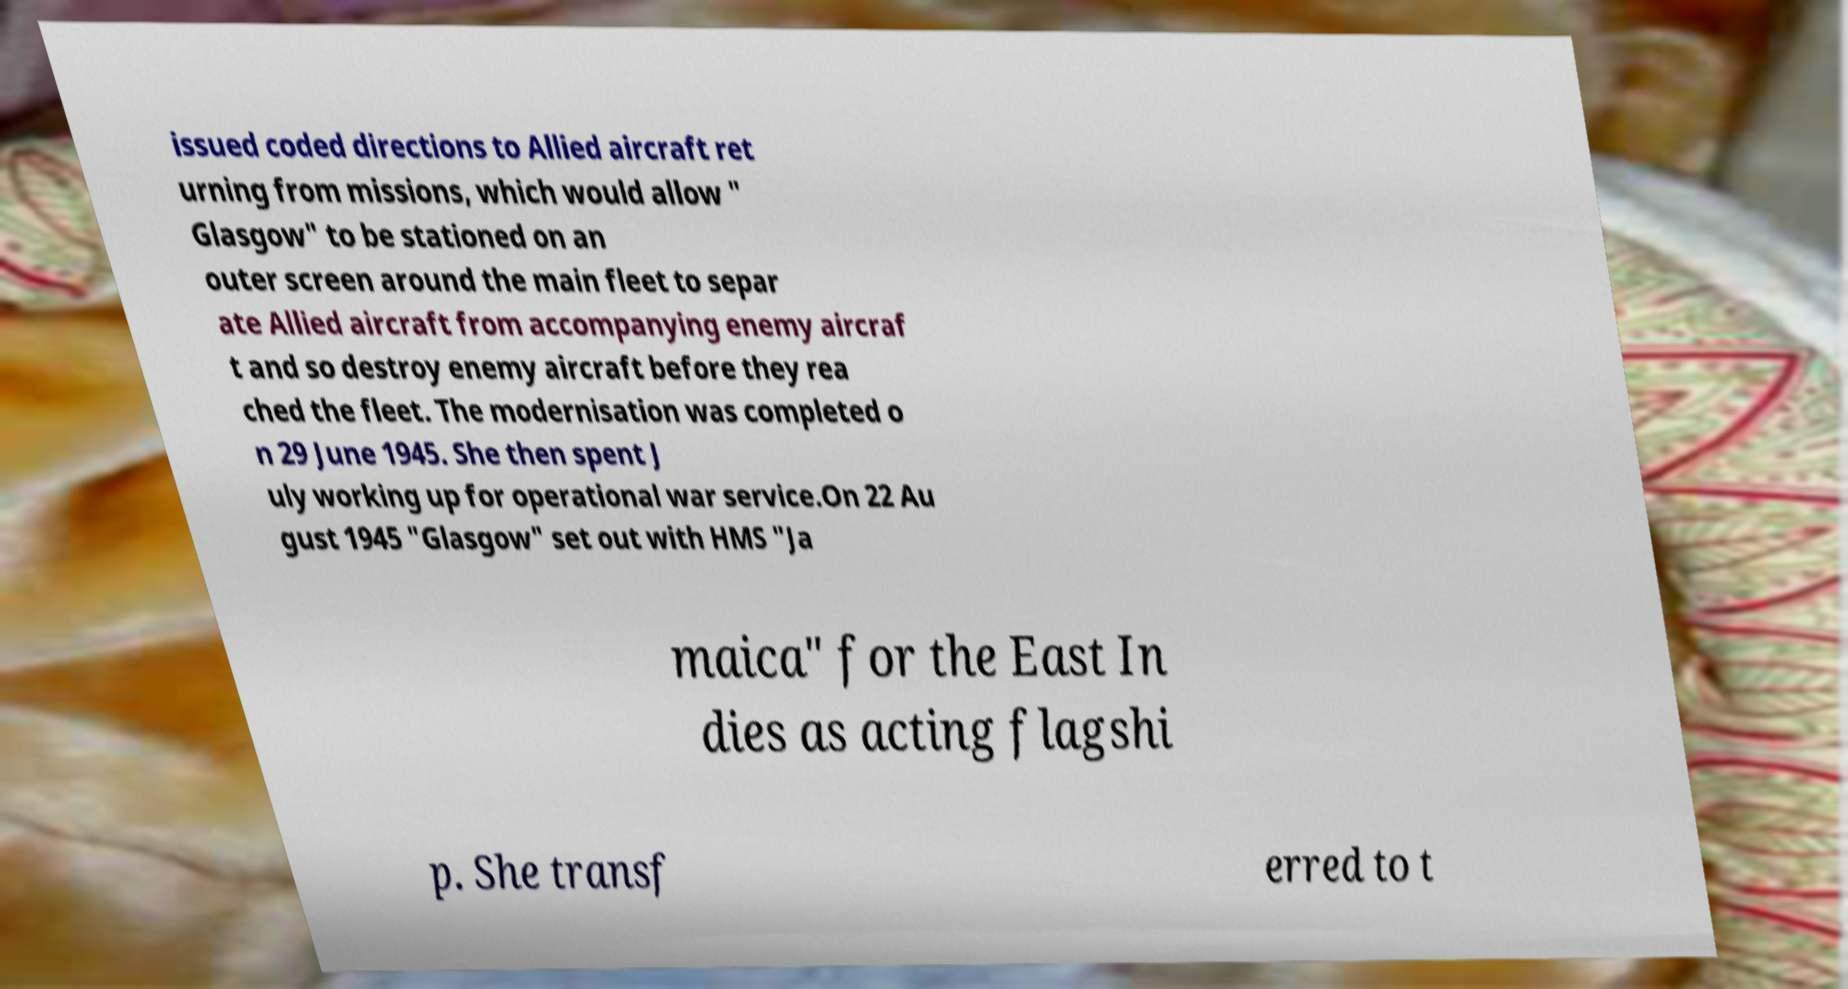Can you read and provide the text displayed in the image?This photo seems to have some interesting text. Can you extract and type it out for me? issued coded directions to Allied aircraft ret urning from missions, which would allow " Glasgow" to be stationed on an outer screen around the main fleet to separ ate Allied aircraft from accompanying enemy aircraf t and so destroy enemy aircraft before they rea ched the fleet. The modernisation was completed o n 29 June 1945. She then spent J uly working up for operational war service.On 22 Au gust 1945 "Glasgow" set out with HMS "Ja maica" for the East In dies as acting flagshi p. She transf erred to t 